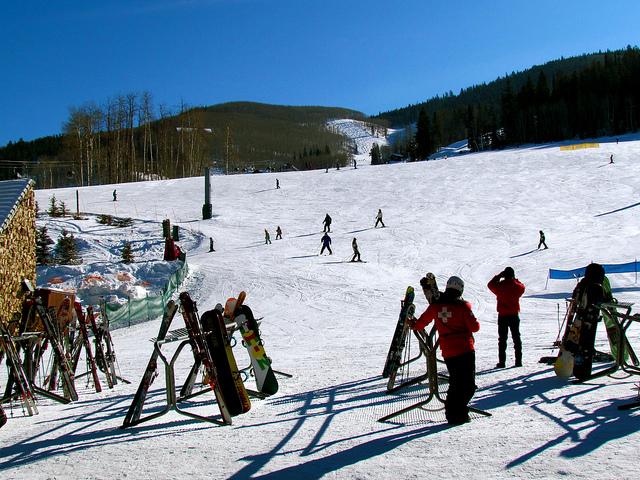Are the people looking at the camera?
Quick response, please. No. Is it cold?
Be succinct. Yes. What sport are these people partaking in?
Be succinct. Snowboarding. 